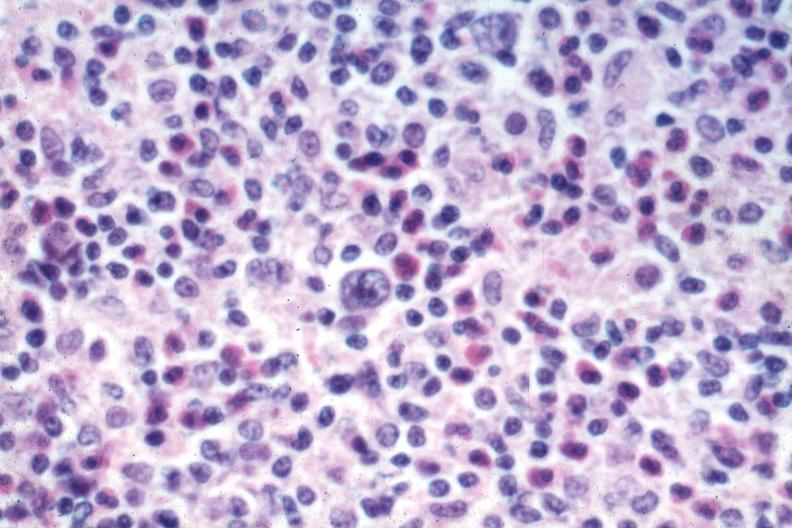what is present?
Answer the question using a single word or phrase. Hodgkins disease 